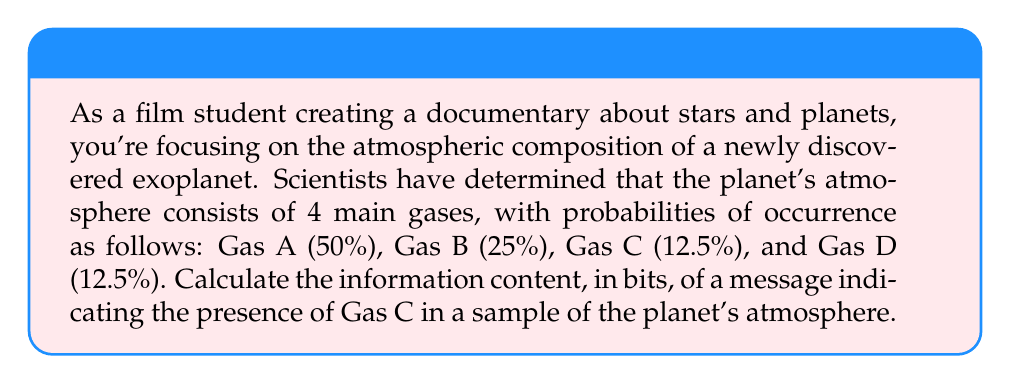Help me with this question. To solve this problem, we'll use the concept of information content from information theory. The information content of an event is measured by how surprising or unexpected the event is. It's calculated using the following formula:

$$I(x) = -\log_2(p(x))$$

Where:
$I(x)$ is the information content of event $x$ in bits
$p(x)$ is the probability of event $x$ occurring

For this problem:
1. We're interested in the information content of detecting Gas C.
2. The probability of Gas C is given as 12.5% or 0.125.

Let's calculate:

$$\begin{align}
I(\text{Gas C}) &= -\log_2(p(\text{Gas C})) \\
&= -\log_2(0.125) \\
&= -\log_2(\frac{1}{8}) \\
&= -(-3) \\
&= 3 \text{ bits}
\end{align}$$

This result means that detecting Gas C in a sample of the planet's atmosphere provides 3 bits of information.

To interpret this for your documentary:
- The higher the information content, the more surprising or informative the event is.
- Gas C (and D) have the highest information content because they are the least likely to be found in a random sample.
- In contrast, detecting Gas A would provide only 1 bit of information ($-\log_2(0.5) = 1$), as it's the most common and thus least surprising to find.
Answer: 3 bits 